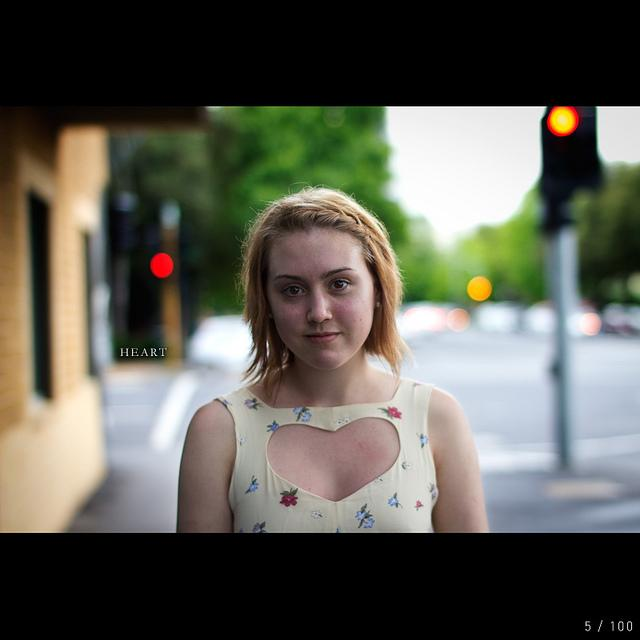What age group is this person in? twenties 